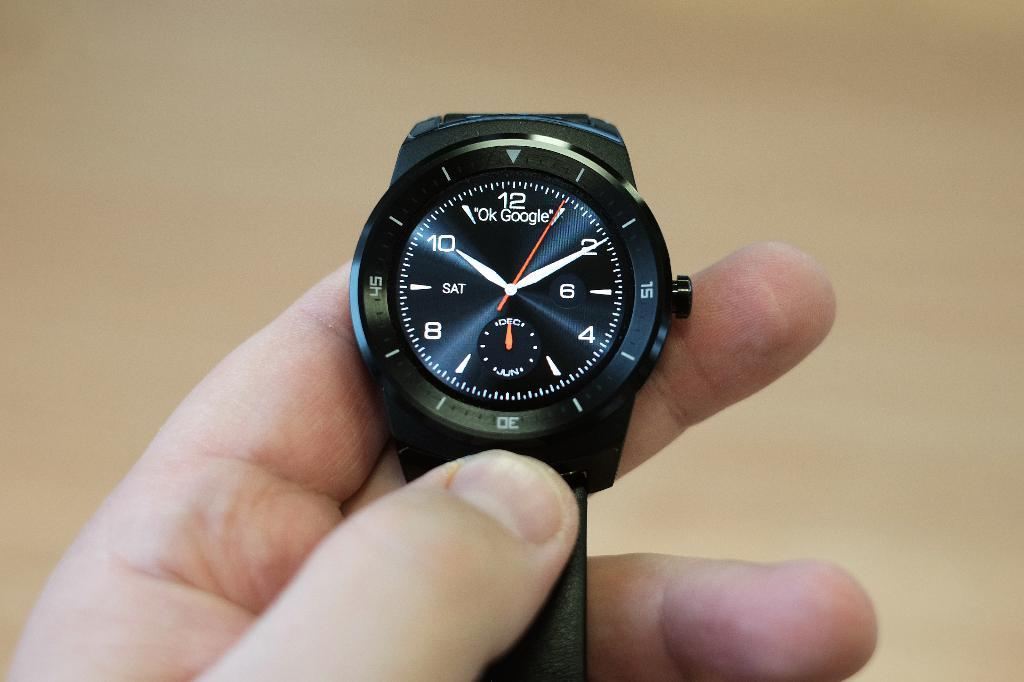Provide a one-sentence caption for the provided image. A watch has the Ok Google logo on the face. 